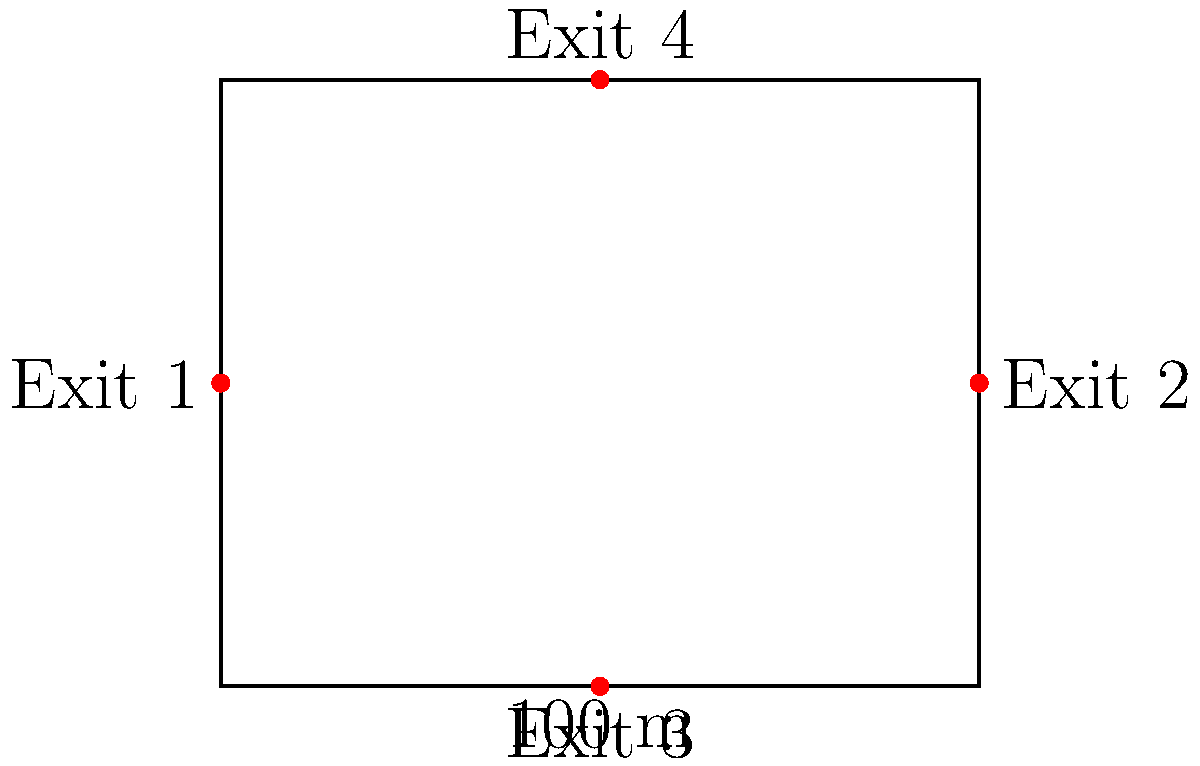As a runway model, you're asked to estimate the maximum crowd capacity for a new fashion venue. The rectangular venue measures 100 m by 80 m and has four exits located at the midpoints of each side, as shown in the floor plan. According to safety regulations, each person requires a minimum of 0.5 m² of space, and there should be at least 1 m of clear path to each exit for every 250 people. What is the estimated maximum crowd capacity for this venue? To estimate the maximum crowd capacity, we need to consider both the floor area and the exit capacity:

1. Floor area calculation:
   - Total area = 100 m × 80 m = 8000 m²
   - Area per person = 0.5 m²
   - Maximum capacity based on area = 8000 m² ÷ 0.5 m² = 16000 people

2. Exit capacity calculation:
   - Number of exits = 4
   - Clear path required = 1 m per 250 people
   - Total exit width = 4 × 100 m = 400 m (assuming full side length is available)
   - Maximum capacity based on exits = (400 m ÷ 1 m) × 250 = 100000 people

3. The limiting factor:
   The maximum crowd capacity will be the lower of the two calculated values, as we need to satisfy both area and exit requirements.

Therefore, the estimated maximum crowd capacity is limited by the floor area and is 16000 people.

However, it's important to note that this is a simplified calculation. In practice, additional factors such as furniture, stage setup, and local building codes would need to be considered for a more accurate estimation.
Answer: 16000 people 